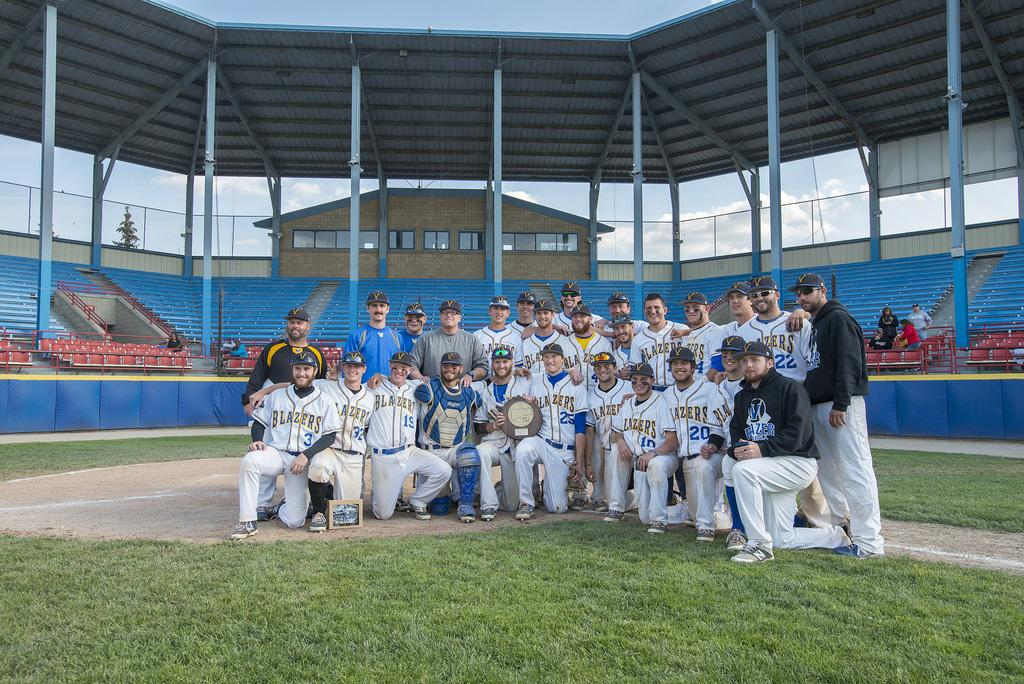<image>
Give a short and clear explanation of the subsequent image. many Blazers players posing for a photo together 